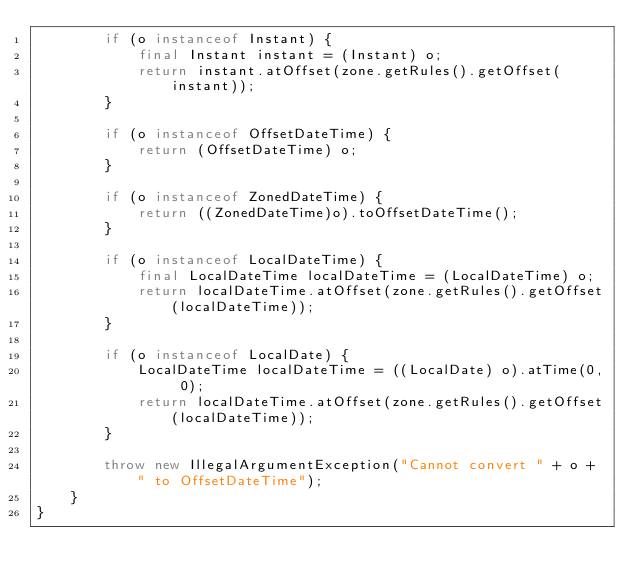<code> <loc_0><loc_0><loc_500><loc_500><_Java_>        if (o instanceof Instant) {
            final Instant instant = (Instant) o;
            return instant.atOffset(zone.getRules().getOffset(instant));
        }

        if (o instanceof OffsetDateTime) {
            return (OffsetDateTime) o;
        }

        if (o instanceof ZonedDateTime) {
            return ((ZonedDateTime)o).toOffsetDateTime();
        }

        if (o instanceof LocalDateTime) {
            final LocalDateTime localDateTime = (LocalDateTime) o;
            return localDateTime.atOffset(zone.getRules().getOffset(localDateTime));
        }

        if (o instanceof LocalDate) {
            LocalDateTime localDateTime = ((LocalDate) o).atTime(0, 0);
            return localDateTime.atOffset(zone.getRules().getOffset(localDateTime));
        }

        throw new IllegalArgumentException("Cannot convert " + o + " to OffsetDateTime");
    }
}
</code> 